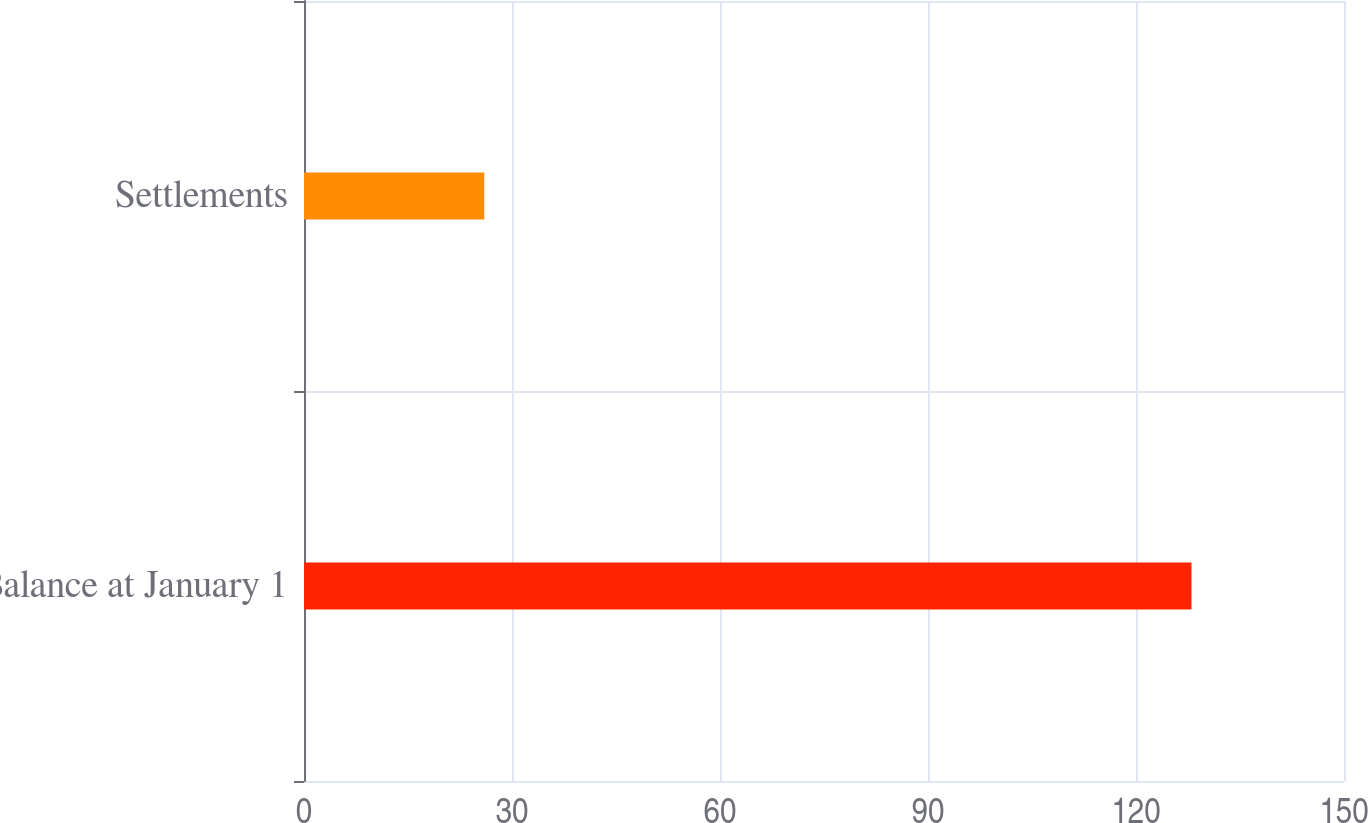Convert chart to OTSL. <chart><loc_0><loc_0><loc_500><loc_500><bar_chart><fcel>Balance at January 1<fcel>Settlements<nl><fcel>128<fcel>26<nl></chart> 